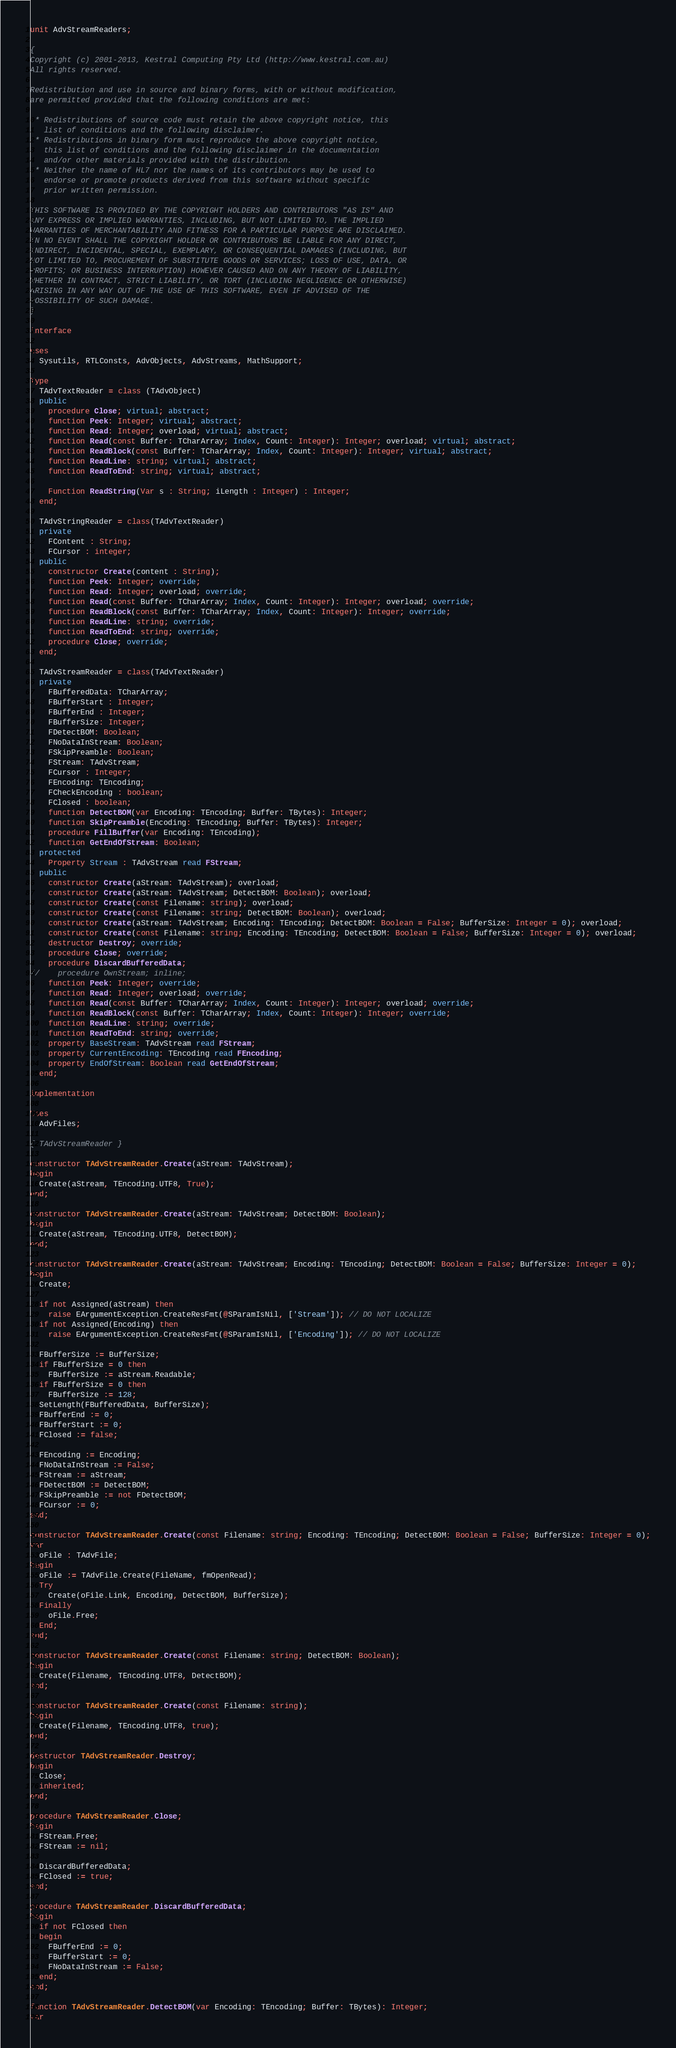<code> <loc_0><loc_0><loc_500><loc_500><_Pascal_>unit AdvStreamReaders;

{
Copyright (c) 2001-2013, Kestral Computing Pty Ltd (http://www.kestral.com.au)
All rights reserved.

Redistribution and use in source and binary forms, with or without modification, 
are permitted provided that the following conditions are met:

 * Redistributions of source code must retain the above copyright notice, this 
   list of conditions and the following disclaimer.
 * Redistributions in binary form must reproduce the above copyright notice, 
   this list of conditions and the following disclaimer in the documentation 
   and/or other materials provided with the distribution.
 * Neither the name of HL7 nor the names of its contributors may be used to 
   endorse or promote products derived from this software without specific 
   prior written permission.

THIS SOFTWARE IS PROVIDED BY THE COPYRIGHT HOLDERS AND CONTRIBUTORS "AS IS" AND 
ANY EXPRESS OR IMPLIED WARRANTIES, INCLUDING, BUT NOT LIMITED TO, THE IMPLIED 
WARRANTIES OF MERCHANTABILITY AND FITNESS FOR A PARTICULAR PURPOSE ARE DISCLAIMED. 
IN NO EVENT SHALL THE COPYRIGHT HOLDER OR CONTRIBUTORS BE LIABLE FOR ANY DIRECT,
INDIRECT, INCIDENTAL, SPECIAL, EXEMPLARY, OR CONSEQUENTIAL DAMAGES (INCLUDING, BUT
NOT LIMITED TO, PROCUREMENT OF SUBSTITUTE GOODS OR SERVICES; LOSS OF USE, DATA, OR
PROFITS; OR BUSINESS INTERRUPTION) HOWEVER CAUSED AND ON ANY THEORY OF LIABILITY,
WHETHER IN CONTRACT, STRICT LIABILITY, OR TORT (INCLUDING NEGLIGENCE OR OTHERWISE)
ARISING IN ANY WAY OUT OF THE USE OF THIS SOFTWARE, EVEN IF ADVISED OF THE
POSSIBILITY OF SUCH DAMAGE.
}

interface

uses
  Sysutils, RTLConsts, AdvObjects, AdvStreams, MathSupport;

Type
  TAdvTextReader = class (TAdvObject)
  public
    procedure Close; virtual; abstract;
    function Peek: Integer; virtual; abstract;
    function Read: Integer; overload; virtual; abstract;
    function Read(const Buffer: TCharArray; Index, Count: Integer): Integer; overload; virtual; abstract;
    function ReadBlock(const Buffer: TCharArray; Index, Count: Integer): Integer; virtual; abstract;
    function ReadLine: string; virtual; abstract;
    function ReadToEnd: string; virtual; abstract;

    Function ReadString(Var s : String; iLength : Integer) : Integer;
  end;

  TAdvStringReader = class(TAdvTextReader)
  private
    FContent : String;
    FCursor : integer;
  public
    constructor Create(content : String);
    function Peek: Integer; override;
    function Read: Integer; overload; override;
    function Read(const Buffer: TCharArray; Index, Count: Integer): Integer; overload; override;
    function ReadBlock(const Buffer: TCharArray; Index, Count: Integer): Integer; override;
    function ReadLine: string; override;
    function ReadToEnd: string; override;
    procedure Close; override;
  end;

  TAdvStreamReader = class(TAdvTextReader)
  private
    FBufferedData: TCharArray;
    FBufferStart : Integer;
    FBufferEnd : Integer;
    FBufferSize: Integer;
    FDetectBOM: Boolean;
    FNoDataInStream: Boolean;
    FSkipPreamble: Boolean;
    FStream: TAdvStream;
    FCursor : Integer;
    FEncoding: TEncoding;
    FCheckEncoding : boolean;
    FClosed : boolean;
    function DetectBOM(var Encoding: TEncoding; Buffer: TBytes): Integer;
    function SkipPreamble(Encoding: TEncoding; Buffer: TBytes): Integer;
    procedure FillBuffer(var Encoding: TEncoding);
    function GetEndOfStream: Boolean;
  protected
    Property Stream : TAdvStream read FStream;
  public
    constructor Create(aStream: TAdvStream); overload;
    constructor Create(aStream: TAdvStream; DetectBOM: Boolean); overload;
    constructor Create(const Filename: string); overload;
    constructor Create(const Filename: string; DetectBOM: Boolean); overload;
    constructor Create(aStream: TAdvStream; Encoding: TEncoding; DetectBOM: Boolean = False; BufferSize: Integer = 0); overload;
    constructor Create(const Filename: string; Encoding: TEncoding; DetectBOM: Boolean = False; BufferSize: Integer = 0); overload;
    destructor Destroy; override;
    procedure Close; override;
    procedure DiscardBufferedData;
//    procedure OwnStream; inline;
    function Peek: Integer; override;
    function Read: Integer; overload; override;
    function Read(const Buffer: TCharArray; Index, Count: Integer): Integer; overload; override;
    function ReadBlock(const Buffer: TCharArray; Index, Count: Integer): Integer; override;
    function ReadLine: string; override;
    function ReadToEnd: string; override;
    property BaseStream: TAdvStream read FStream;
    property CurrentEncoding: TEncoding read FEncoding;
    property EndOfStream: Boolean read GetEndOfStream;
  end;

implementation

Uses
  AdvFiles;

{ TAdvStreamReader }

constructor TAdvStreamReader.Create(aStream: TAdvStream);
begin
  Create(aStream, TEncoding.UTF8, True);
end;

constructor TAdvStreamReader.Create(aStream: TAdvStream; DetectBOM: Boolean);
begin
  Create(aStream, TEncoding.UTF8, DetectBOM);
end;

constructor TAdvStreamReader.Create(aStream: TAdvStream; Encoding: TEncoding; DetectBOM: Boolean = False; BufferSize: Integer = 0);
begin
  Create;

  if not Assigned(aStream) then
    raise EArgumentException.CreateResFmt(@SParamIsNil, ['Stream']); // DO NOT LOCALIZE
  if not Assigned(Encoding) then
    raise EArgumentException.CreateResFmt(@SParamIsNil, ['Encoding']); // DO NOT LOCALIZE

  FBufferSize := BufferSize;
  if FBufferSize = 0 then
    FBufferSize := aStream.Readable;
  if FBufferSize = 0 then
    FBufferSize := 128;
  SetLength(FBufferedData, BufferSize);
  FBufferEnd := 0;
  FBufferStart := 0;
  FClosed := false;

  FEncoding := Encoding;
  FNoDataInStream := False;
  FStream := aStream;
  FDetectBOM := DetectBOM;
  FSkipPreamble := not FDetectBOM;
  FCursor := 0;
end;

constructor TAdvStreamReader.Create(const Filename: string; Encoding: TEncoding; DetectBOM: Boolean = False; BufferSize: Integer = 0);
var
  oFile : TAdvFile;
begin
  oFile := TAdvFile.Create(FileName, fmOpenRead);
  Try
    Create(oFile.Link, Encoding, DetectBOM, BufferSize);
  Finally
    oFile.Free;
  End;
end;

constructor TAdvStreamReader.Create(const Filename: string; DetectBOM: Boolean);
begin
  Create(Filename, TEncoding.UTF8, DetectBOM);
end;

constructor TAdvStreamReader.Create(const Filename: string);
begin
  Create(Filename, TEncoding.UTF8, true);
end;

destructor TAdvStreamReader.Destroy;
begin
  Close;
  inherited;
end;

procedure TAdvStreamReader.Close;
begin
  FStream.Free;
  FStream := nil;

  DiscardBufferedData;
  FClosed := true;
end;

procedure TAdvStreamReader.DiscardBufferedData;
begin
  if not FClosed then
  begin
    FBufferEnd := 0;
    FBufferStart := 0;
    FNoDataInStream := False;
  end;
end;

function TAdvStreamReader.DetectBOM(var Encoding: TEncoding; Buffer: TBytes): Integer;
var</code> 